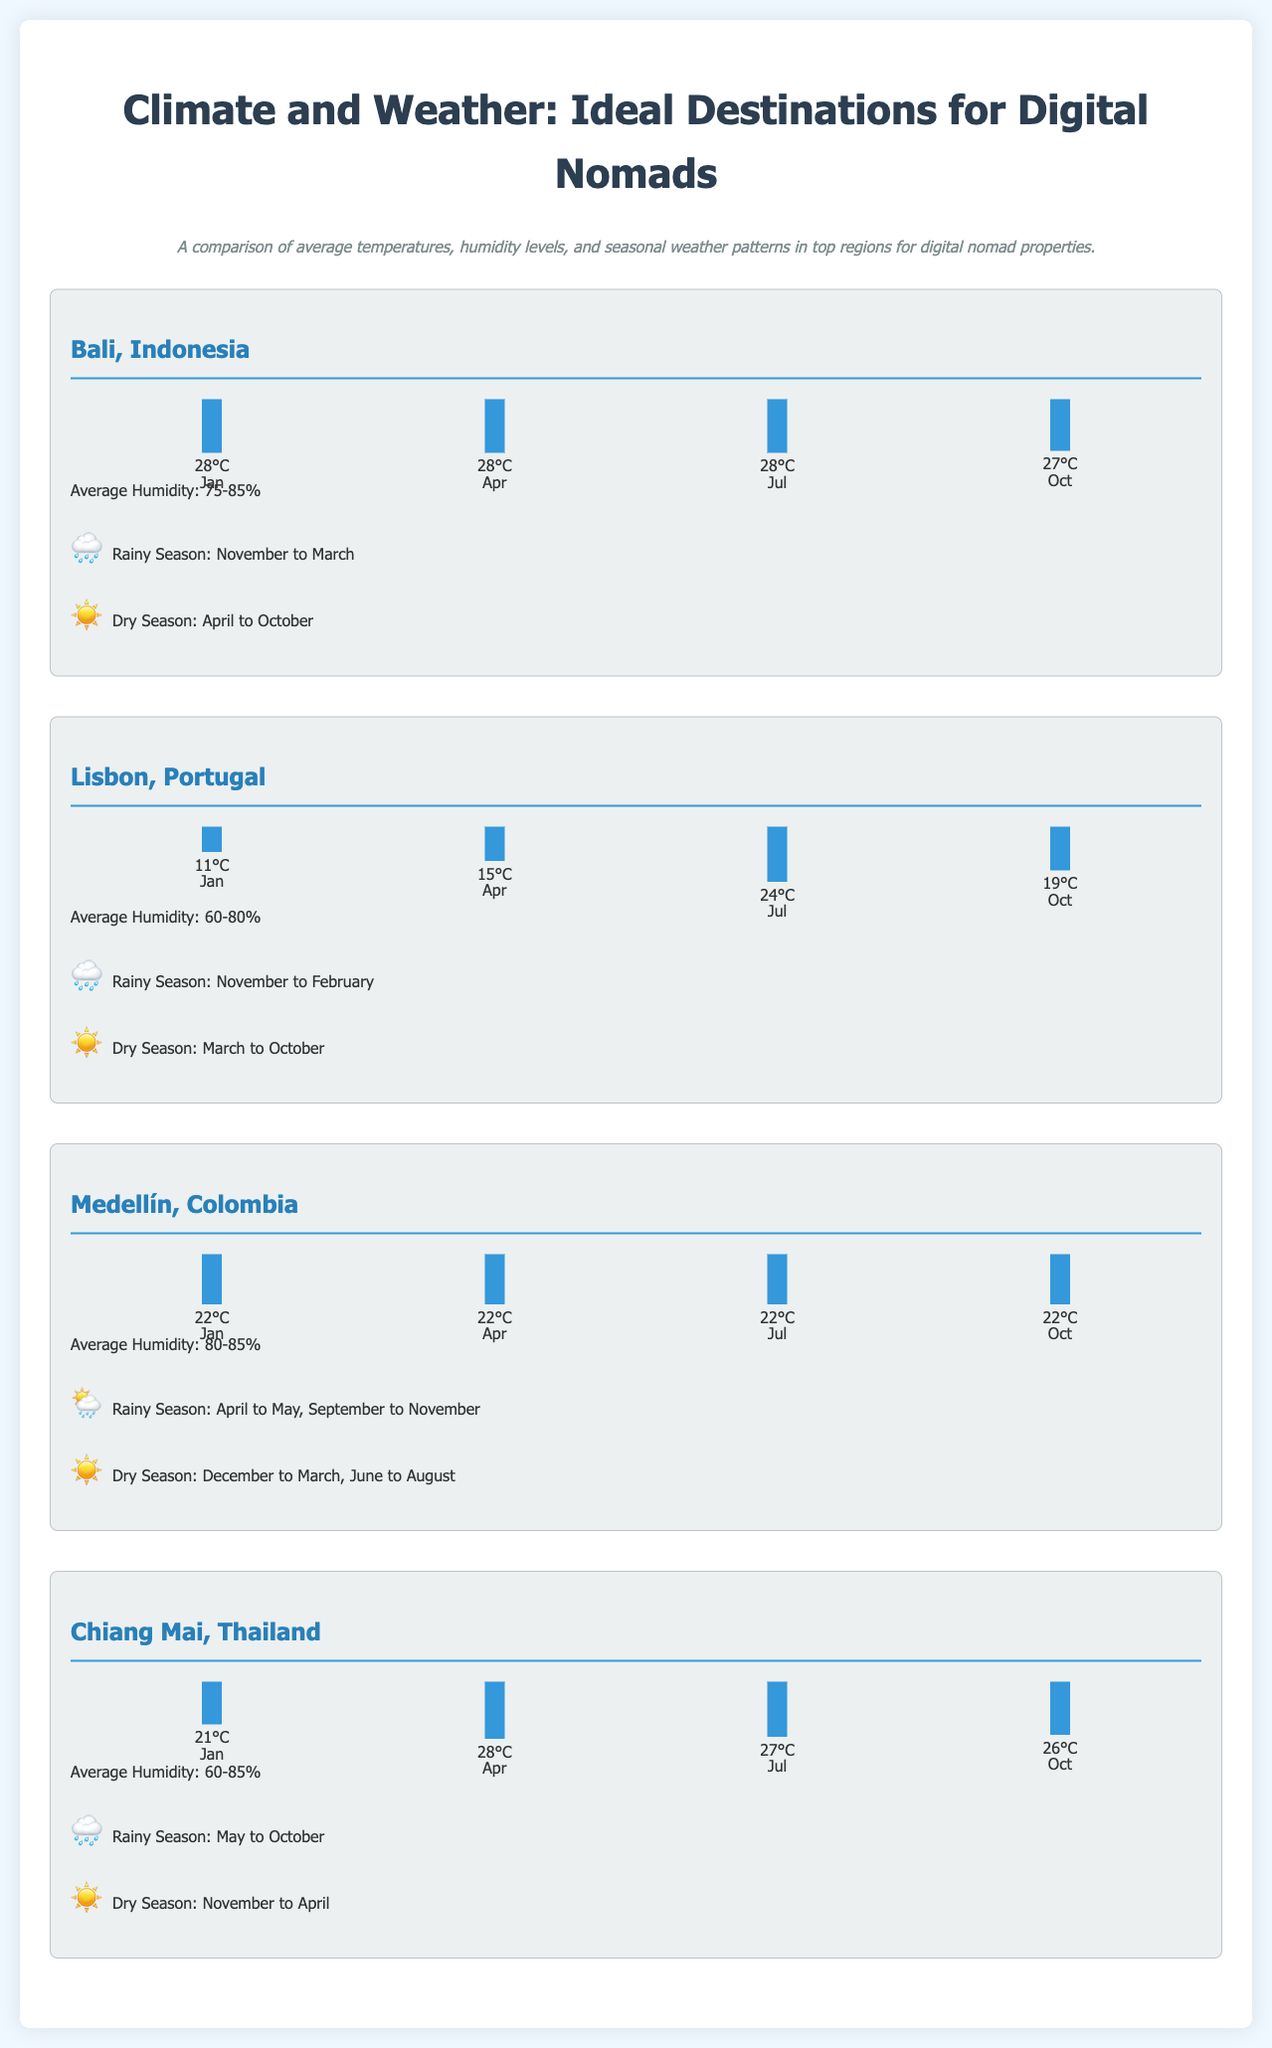What is the average humidity in Bali, Indonesia? The average humidity for Bali, Indonesia is stated in the document as 75-85%.
Answer: 75-85% What is the highest average temperature in Lisbon, Portugal? The highest average temperature in Lisbon is given in July, which is 24°C.
Answer: 24°C When does the rainy season occur in Chiang Mai, Thailand? The rainy season in Chiang Mai is indicated as May to October in the document.
Answer: May to October Which region has a consistent monthly average temperature of 22°C? The document states that Medellín, Colombia has a consistent temperature of 22°C across all months shown.
Answer: Medellín, Colombia What is the average humidity level in Medellín, Colombia? The average humidity level in Medellín is provided as 80-85% in the document.
Answer: 80-85% What temperature chart month corresponds to a 93.33% height in Bali? The temperature chart shows 93.33% in Bali for the months of January, April, and July.
Answer: January, April, July Which region experiences a dry season from November to April? The dry season from November to April applies to Chiang Mai, Thailand as per the document.
Answer: Chiang Mai What is the average temperature in January for Lisbon, Portugal? The average temperature in January for Lisbon is detailed as 11°C in the document.
Answer: 11°C Which region's rainy season overlaps with the months of September to November? The rainy season from April to May and September to November is mentioned for Medellín, Colombia.
Answer: Medellín, Colombia 